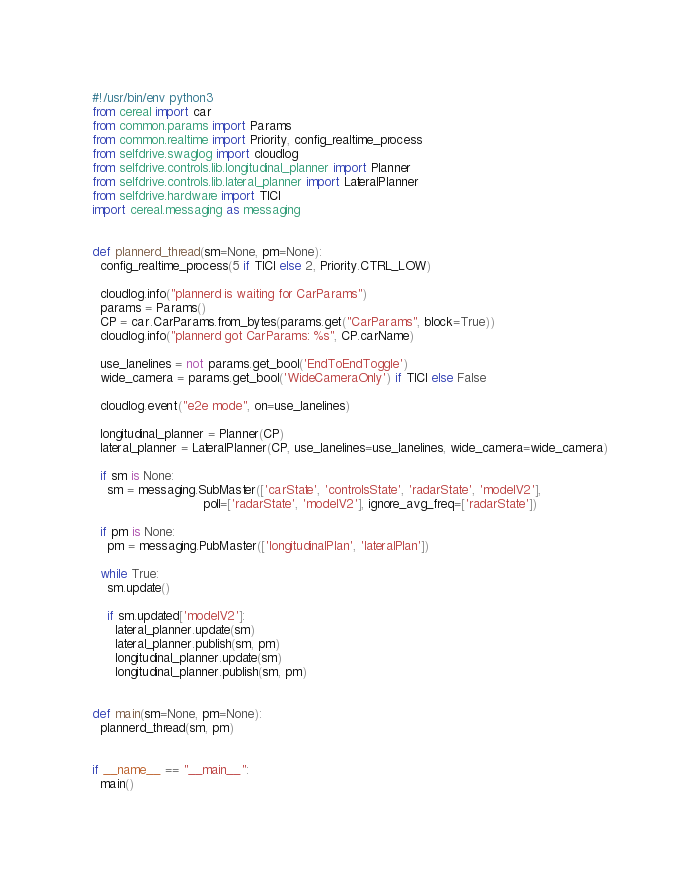Convert code to text. <code><loc_0><loc_0><loc_500><loc_500><_Python_>#!/usr/bin/env python3
from cereal import car
from common.params import Params
from common.realtime import Priority, config_realtime_process
from selfdrive.swaglog import cloudlog
from selfdrive.controls.lib.longitudinal_planner import Planner
from selfdrive.controls.lib.lateral_planner import LateralPlanner
from selfdrive.hardware import TICI
import cereal.messaging as messaging


def plannerd_thread(sm=None, pm=None):
  config_realtime_process(5 if TICI else 2, Priority.CTRL_LOW)

  cloudlog.info("plannerd is waiting for CarParams")
  params = Params()
  CP = car.CarParams.from_bytes(params.get("CarParams", block=True))
  cloudlog.info("plannerd got CarParams: %s", CP.carName)

  use_lanelines = not params.get_bool('EndToEndToggle')
  wide_camera = params.get_bool('WideCameraOnly') if TICI else False

  cloudlog.event("e2e mode", on=use_lanelines)

  longitudinal_planner = Planner(CP)
  lateral_planner = LateralPlanner(CP, use_lanelines=use_lanelines, wide_camera=wide_camera)

  if sm is None:
    sm = messaging.SubMaster(['carState', 'controlsState', 'radarState', 'modelV2'],
                             poll=['radarState', 'modelV2'], ignore_avg_freq=['radarState'])

  if pm is None:
    pm = messaging.PubMaster(['longitudinalPlan', 'lateralPlan'])

  while True:
    sm.update()

    if sm.updated['modelV2']:
      lateral_planner.update(sm)
      lateral_planner.publish(sm, pm)
      longitudinal_planner.update(sm)
      longitudinal_planner.publish(sm, pm)


def main(sm=None, pm=None):
  plannerd_thread(sm, pm)


if __name__ == "__main__":
  main()
</code> 